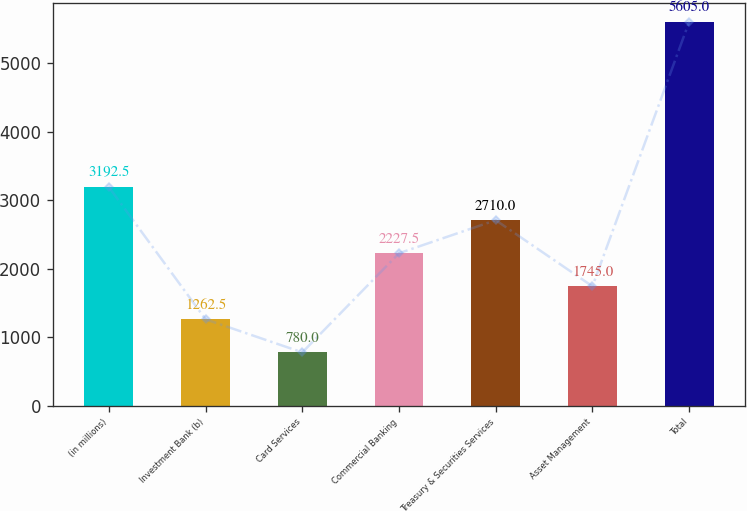<chart> <loc_0><loc_0><loc_500><loc_500><bar_chart><fcel>(in millions)<fcel>Investment Bank (b)<fcel>Card Services<fcel>Commercial Banking<fcel>Treasury & Securities Services<fcel>Asset Management<fcel>Total<nl><fcel>3192.5<fcel>1262.5<fcel>780<fcel>2227.5<fcel>2710<fcel>1745<fcel>5605<nl></chart> 